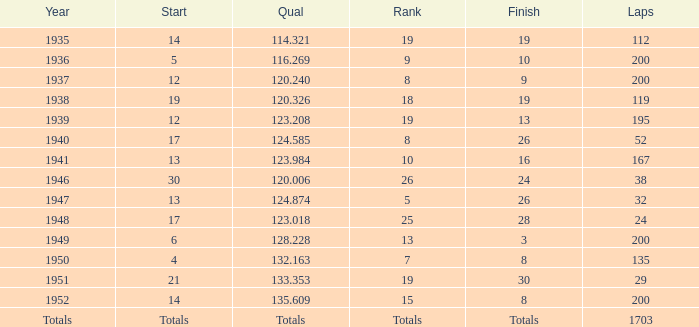006 happened in what year? 1946.0. 